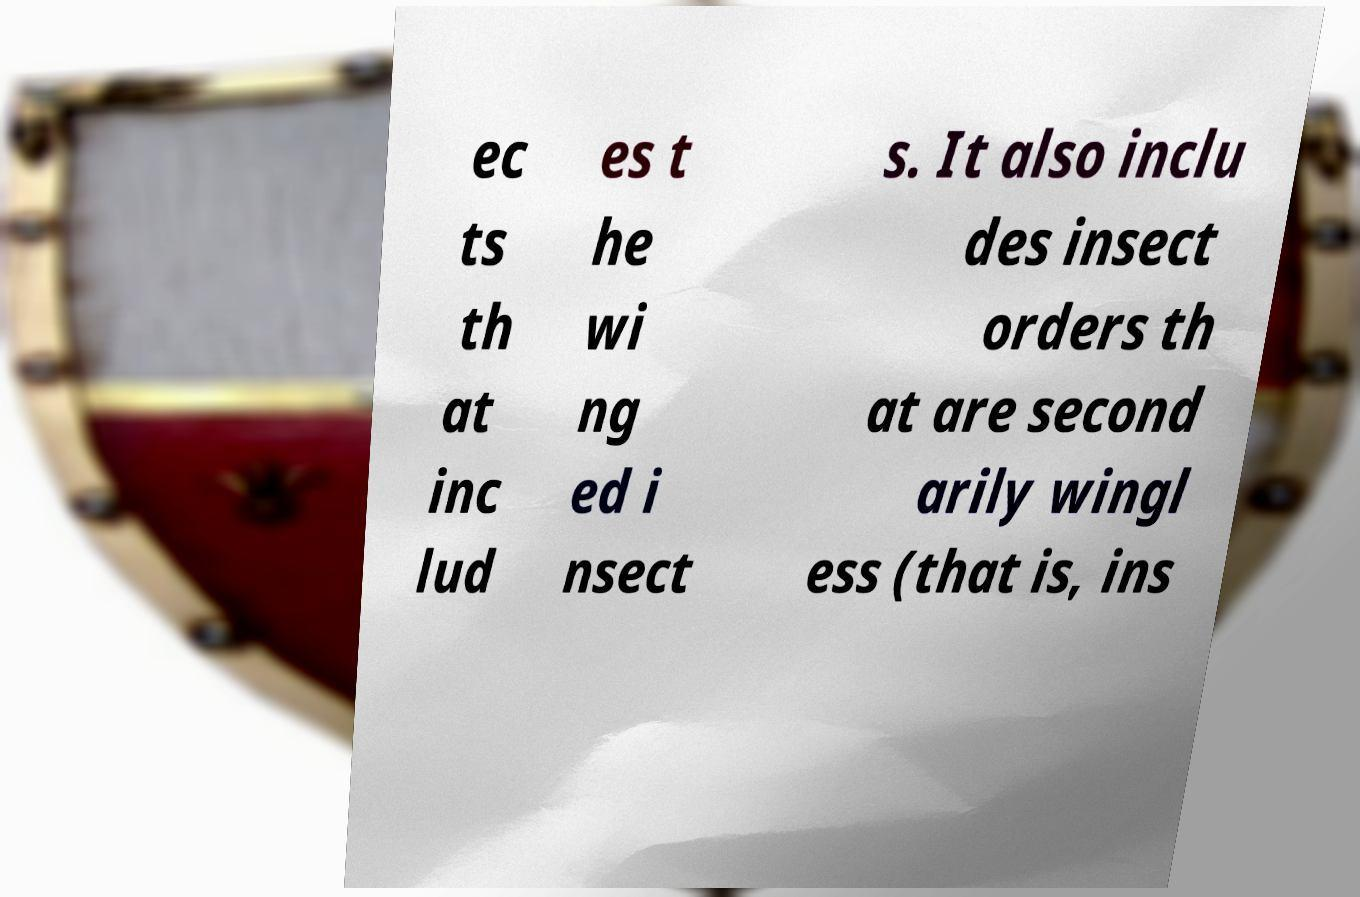Please identify and transcribe the text found in this image. ec ts th at inc lud es t he wi ng ed i nsect s. It also inclu des insect orders th at are second arily wingl ess (that is, ins 